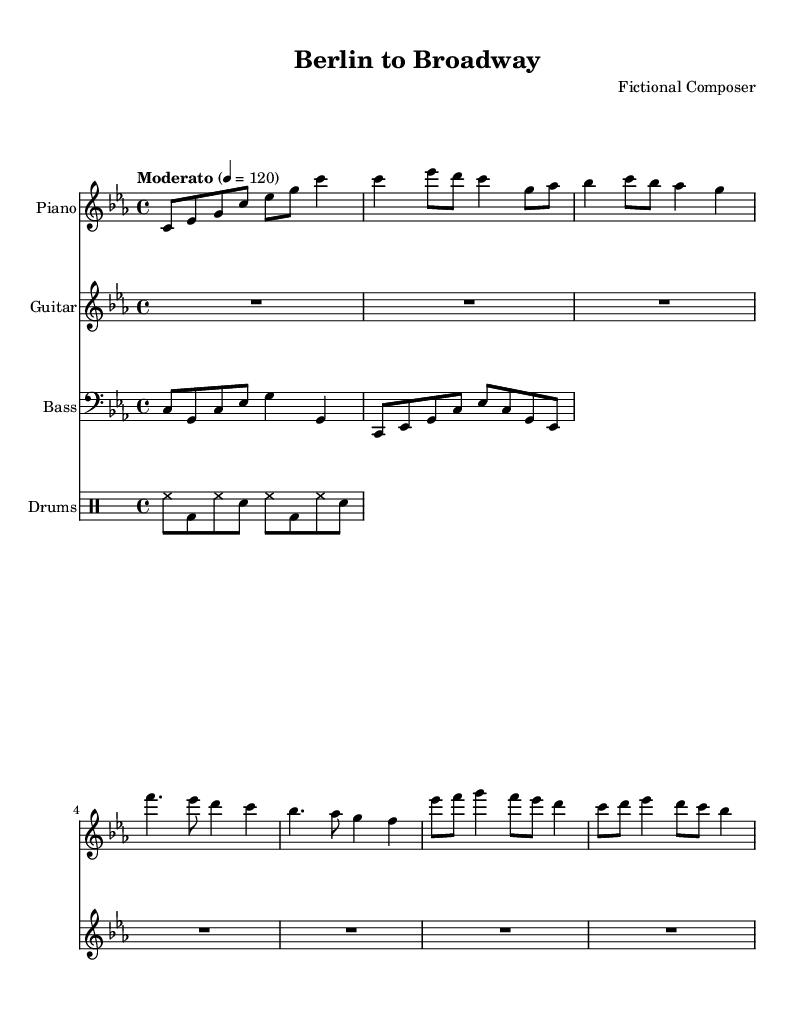What is the key signature of this music? The key signature is C minor, which has three flats (B flat, E flat, and A flat). This can be deduced by looking at the key signature indicator at the beginning of the staff, which specifies C minor.
Answer: C minor What is the time signature of this music? The time signature is indicated as 4/4, meaning there are four beats per measure and the quarter note gets one beat. This is shown at the start of the music notation in the time signature marking.
Answer: 4/4 What is the tempo of this piece? The tempo is marked as "Moderato" with a metronome marking of 120 beats per minute. This is identified from the tempo indication at the beginning of the score.
Answer: Moderato, 120 How many measures are in the piano part? The piano part contains eight measures. This can be counted by looking at the bar lines in the notation that separate the measures.
Answer: 8 What type of music composition is represented here? The piece is a jazz fusion composition, which blends elements of jazz with other musical styles. This is derived from the context of the title and the arrangement incorporating jazz harmonies and rhythms.
Answer: Jazz fusion What is the role of the guitar in this piece? The guitar part is marked as a rest for the entire piece, which indicates that it is not played in this section. This can be seen from the "R1*7" notation in the guitar staff.
Answer: Rest Which instruments are included in this score? The score features piano, guitar, bass, and drums, as specified at the start of each staff for each instrument. This includes the respective notation for each in the format of the score.
Answer: Piano, guitar, bass, drums 